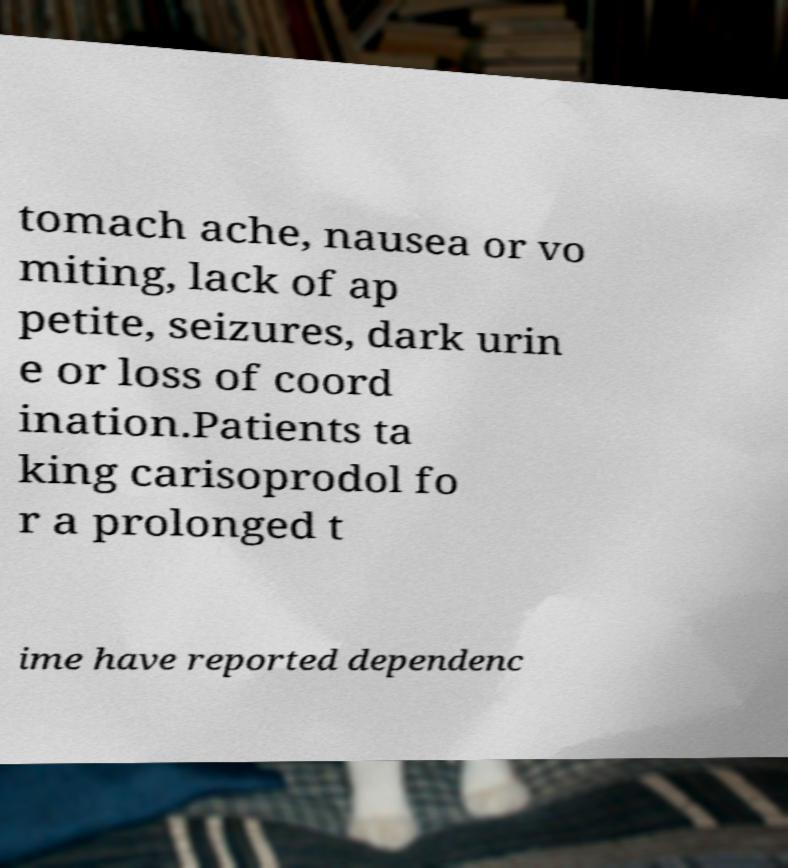Please read and relay the text visible in this image. What does it say? tomach ache, nausea or vo miting, lack of ap petite, seizures, dark urin e or loss of coord ination.Patients ta king carisoprodol fo r a prolonged t ime have reported dependenc 